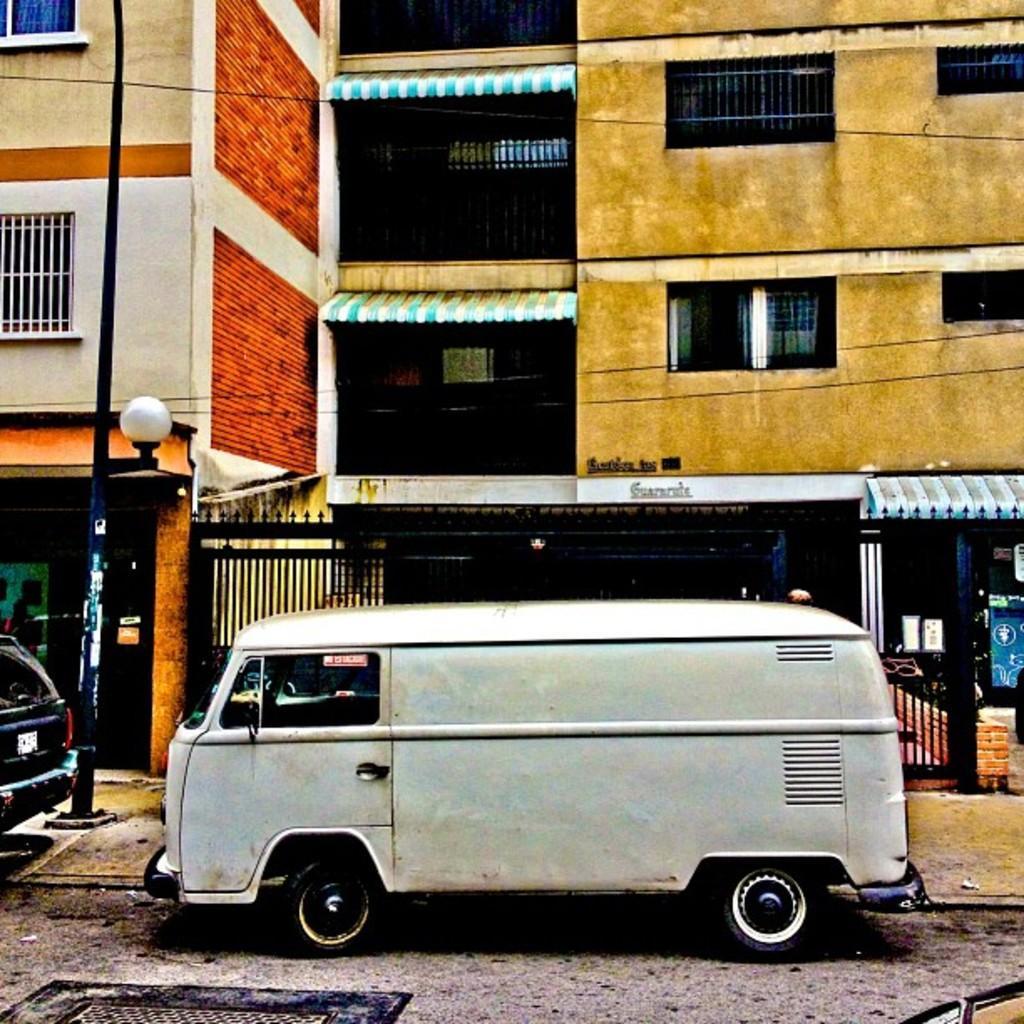In one or two sentences, can you explain what this image depicts? In this picture we can see few vehicles on the road, beside to the vehicles we can find a pole, few buildings, light and a metal door. 